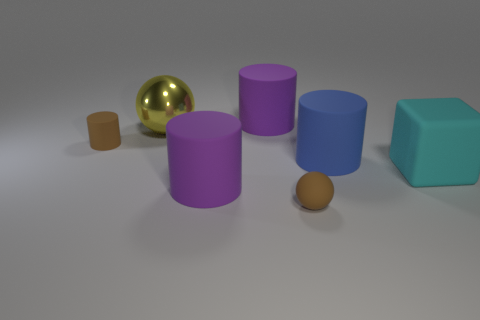How many things are either blue matte cylinders behind the cyan rubber block or big cylinders on the left side of the tiny ball?
Your answer should be compact. 3. What is the size of the blue cylinder that is made of the same material as the cyan cube?
Your response must be concise. Large. Do the purple object in front of the big cyan thing and the cyan matte object have the same shape?
Offer a terse response. No. What is the size of the thing that is the same color as the tiny sphere?
Give a very brief answer. Small. What number of purple things are large cubes or big shiny things?
Offer a very short reply. 0. What number of other things are there of the same shape as the cyan matte thing?
Your answer should be very brief. 0. The object that is behind the blue matte object and to the right of the large yellow sphere has what shape?
Keep it short and to the point. Cylinder. Are there any large rubber things in front of the big blue cylinder?
Make the answer very short. Yes. What is the size of the other brown thing that is the same shape as the big metallic thing?
Your response must be concise. Small. Is there any other thing that has the same size as the blue cylinder?
Give a very brief answer. Yes. 